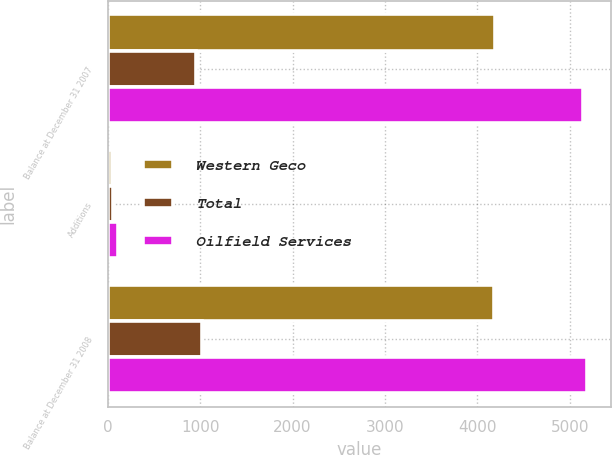<chart> <loc_0><loc_0><loc_500><loc_500><stacked_bar_chart><ecel><fcel>Balance at December 31 2007<fcel>Additions<fcel>Balance at December 31 2008<nl><fcel>Western Geco<fcel>4185<fcel>49<fcel>4174<nl><fcel>Total<fcel>957<fcel>58<fcel>1015<nl><fcel>Oilfield Services<fcel>5142<fcel>107<fcel>5189<nl></chart> 